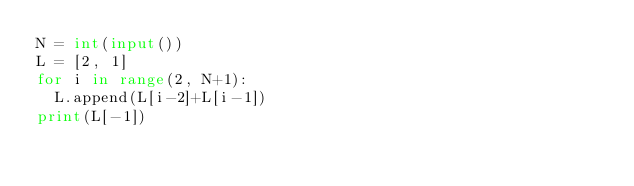Convert code to text. <code><loc_0><loc_0><loc_500><loc_500><_Python_>N = int(input())
L = [2, 1]
for i in range(2, N+1):
  L.append(L[i-2]+L[i-1])
print(L[-1])</code> 